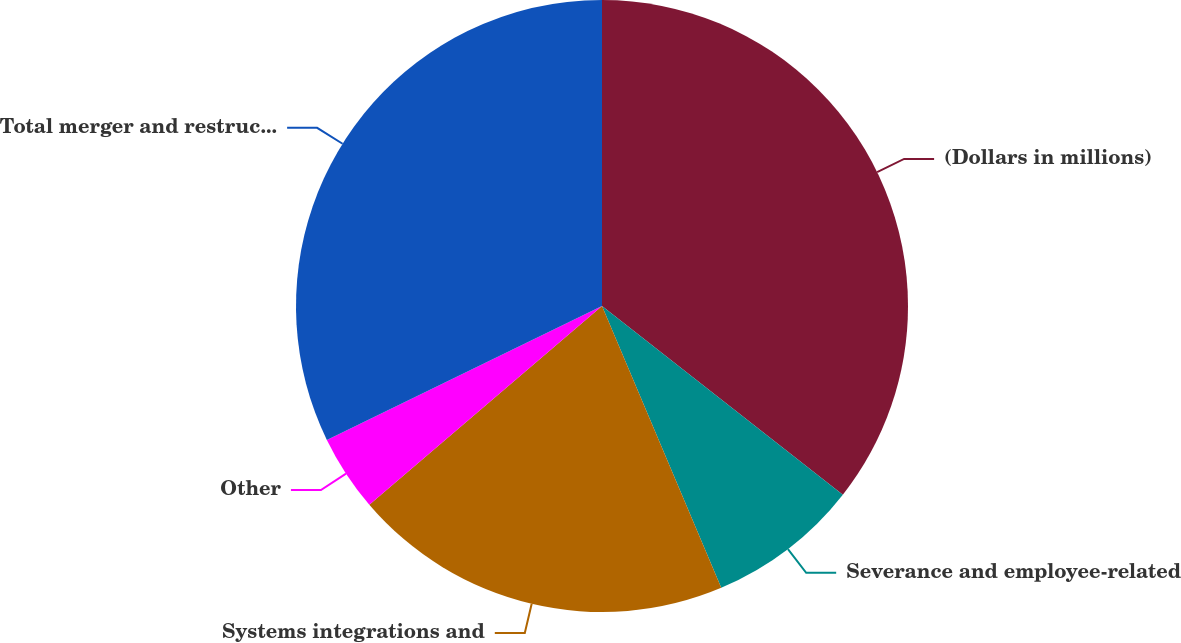<chart> <loc_0><loc_0><loc_500><loc_500><pie_chart><fcel>(Dollars in millions)<fcel>Severance and employee-related<fcel>Systems integrations and<fcel>Other<fcel>Total merger and restructuring<nl><fcel>35.58%<fcel>8.05%<fcel>20.12%<fcel>4.04%<fcel>32.21%<nl></chart> 